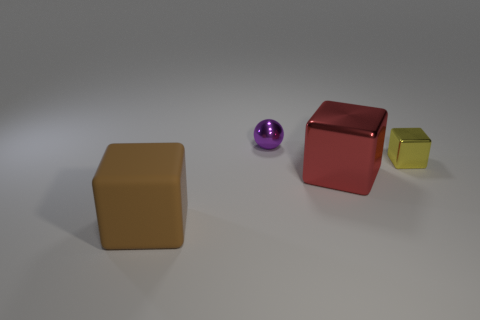Does the block to the right of the big red object have the same material as the sphere?
Provide a short and direct response. Yes. How many yellow blocks are there?
Your answer should be compact. 1. What number of things are small yellow things or green cubes?
Give a very brief answer. 1. How many big metallic blocks are in front of the object behind the tiny thing in front of the purple thing?
Provide a short and direct response. 1. Is the number of brown objects that are behind the small yellow metallic cube greater than the number of large brown blocks that are on the right side of the rubber block?
Give a very brief answer. No. What material is the red object?
Provide a short and direct response. Metal. There is a small thing that is to the right of the metal thing to the left of the big cube that is behind the big matte cube; what is its shape?
Keep it short and to the point. Cube. How many other things are there of the same material as the small yellow object?
Your answer should be compact. 2. Is the material of the tiny object in front of the small metallic sphere the same as the block that is left of the big red object?
Make the answer very short. No. How many metal objects are in front of the metal ball and behind the large metallic block?
Ensure brevity in your answer.  1. 